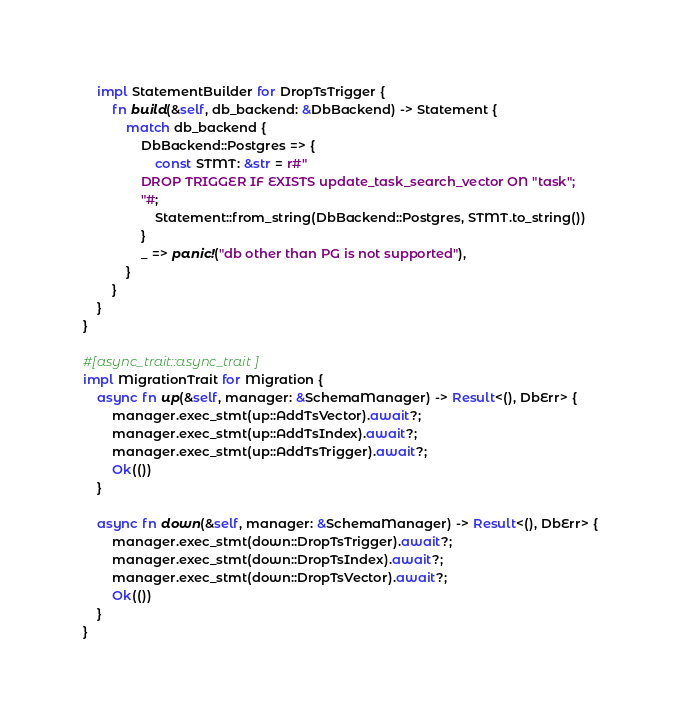<code> <loc_0><loc_0><loc_500><loc_500><_Rust_>    impl StatementBuilder for DropTsTrigger {
        fn build(&self, db_backend: &DbBackend) -> Statement {
            match db_backend {
                DbBackend::Postgres => {
                    const STMT: &str = r#"
                DROP TRIGGER IF EXISTS update_task_search_vector ON "task";
                "#;
                    Statement::from_string(DbBackend::Postgres, STMT.to_string())
                }
                _ => panic!("db other than PG is not supported"),
            }
        }
    }
}

#[async_trait::async_trait]
impl MigrationTrait for Migration {
    async fn up(&self, manager: &SchemaManager) -> Result<(), DbErr> {
        manager.exec_stmt(up::AddTsVector).await?;
        manager.exec_stmt(up::AddTsIndex).await?;
        manager.exec_stmt(up::AddTsTrigger).await?;
        Ok(())
    }

    async fn down(&self, manager: &SchemaManager) -> Result<(), DbErr> {
        manager.exec_stmt(down::DropTsTrigger).await?;
        manager.exec_stmt(down::DropTsIndex).await?;
        manager.exec_stmt(down::DropTsVector).await?;
        Ok(())
    }
}
</code> 